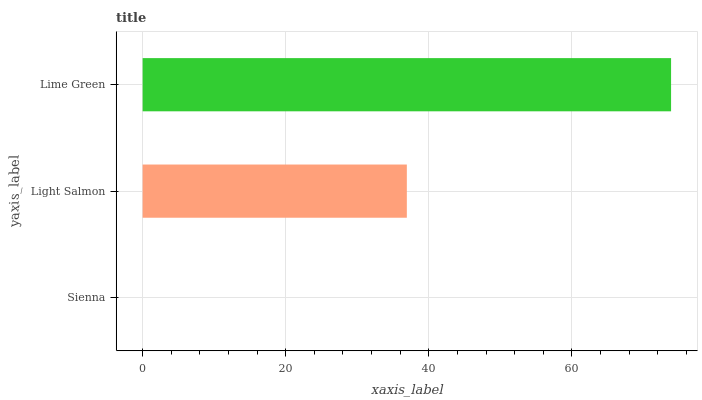Is Sienna the minimum?
Answer yes or no. Yes. Is Lime Green the maximum?
Answer yes or no. Yes. Is Light Salmon the minimum?
Answer yes or no. No. Is Light Salmon the maximum?
Answer yes or no. No. Is Light Salmon greater than Sienna?
Answer yes or no. Yes. Is Sienna less than Light Salmon?
Answer yes or no. Yes. Is Sienna greater than Light Salmon?
Answer yes or no. No. Is Light Salmon less than Sienna?
Answer yes or no. No. Is Light Salmon the high median?
Answer yes or no. Yes. Is Light Salmon the low median?
Answer yes or no. Yes. Is Sienna the high median?
Answer yes or no. No. Is Sienna the low median?
Answer yes or no. No. 